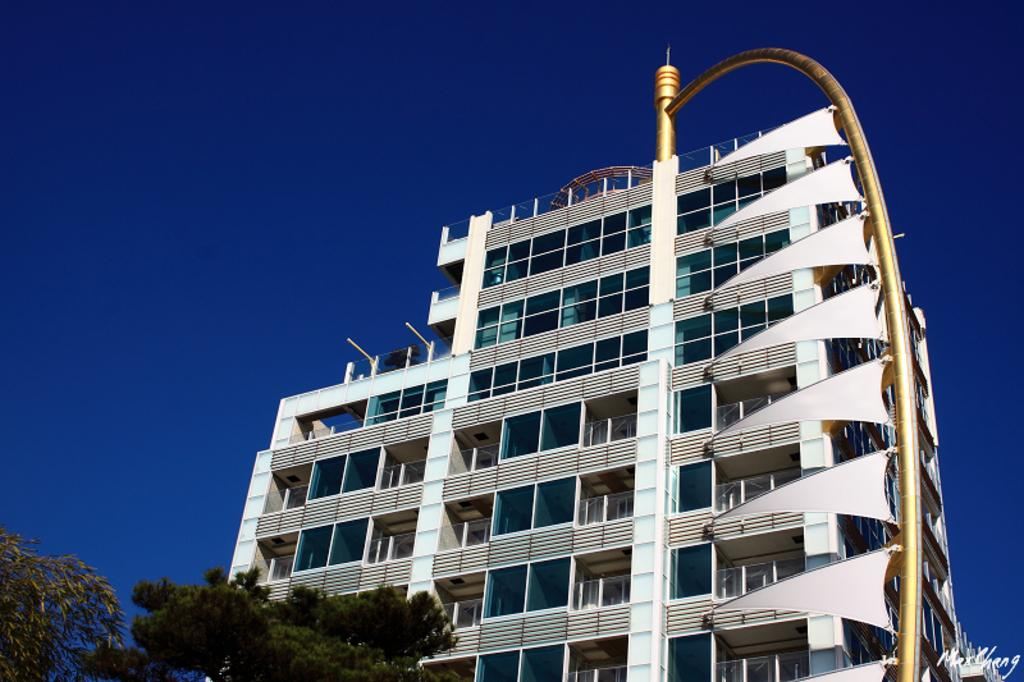What type of structure is present in the image? There is a building in the image. What other natural elements can be seen in the image? There are trees in the image. What type of architectural feature is visible in the image? There is a grille in the image. What is visible in the background of the image? The sky is visible in the image. How many passengers are waiting for the operation to begin in the image? There is no indication of passengers or an operation in the image; it features a building, trees, a grille, and the sky. 